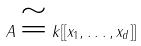<formula> <loc_0><loc_0><loc_500><loc_500>A \cong k [ [ x _ { 1 } , \dots , x _ { d } ] ]</formula> 